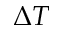Convert formula to latex. <formula><loc_0><loc_0><loc_500><loc_500>\Delta T</formula> 